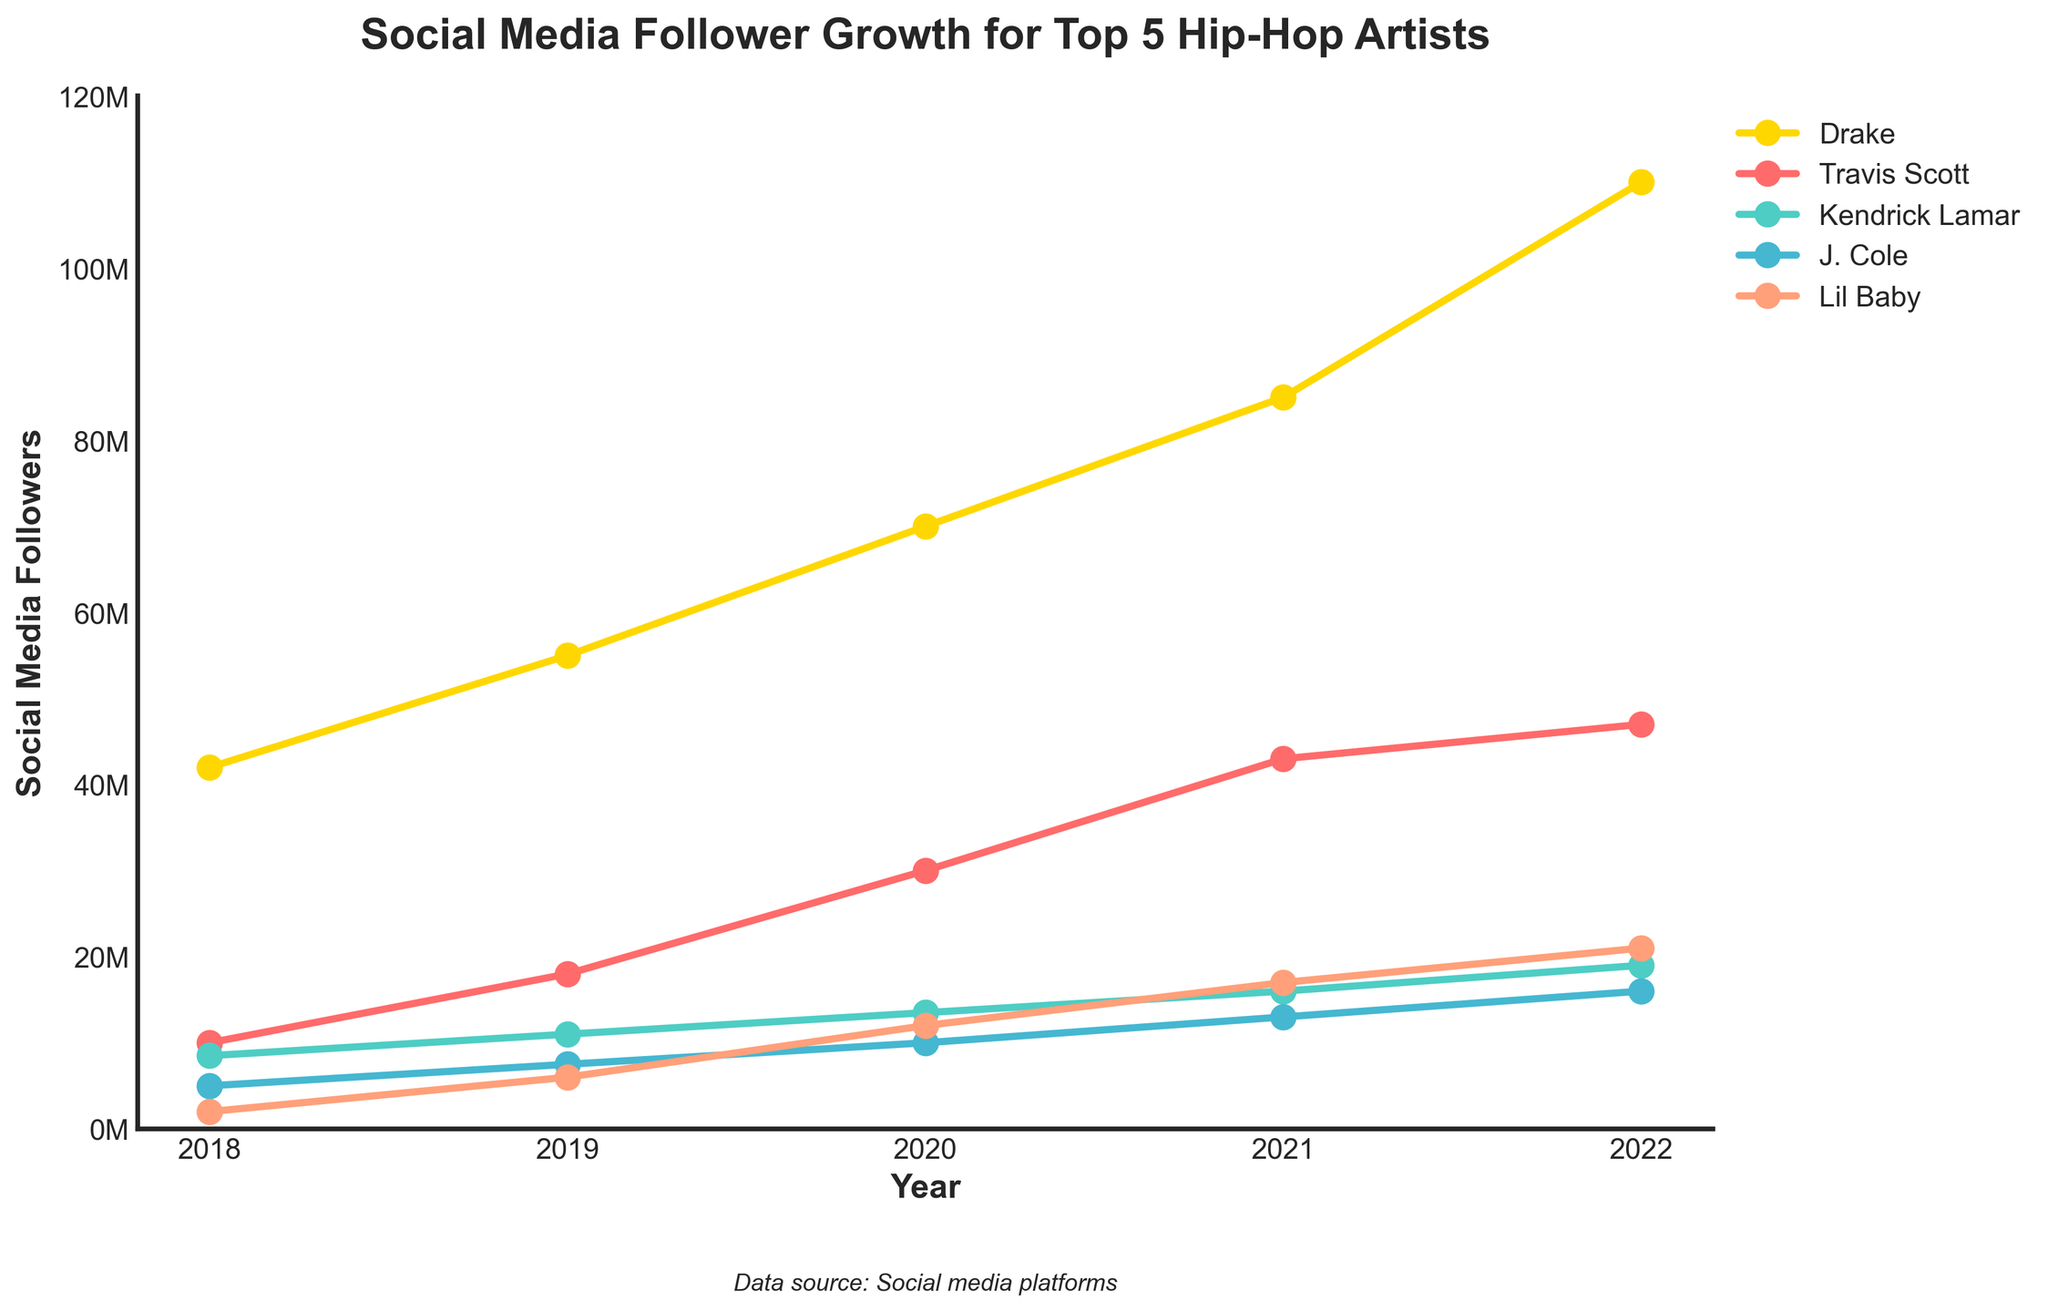What was the difference in social media followers for Lil Baby between 2019 and 2020? In 2019, Lil Baby had 6,000,000 followers, and in 2020, he had 12,000,000 followers. The difference is 12,000,000 - 6,000,000 = 6,000,000 followers.
Answer: 6,000,000 Which artist had the highest social media followers in 2021? In 2021, the artist with the highest social media followers is the one whose line reaches the highest point on the plot. Drake had 85,000,000 followers, which is the highest among the artists.
Answer: Drake What is the average social media followers for J. Cole over the 5-year period? Summing the followers for J. Cole from 2018 to 2022 (5,000,000 + 7,500,000 + 10,000,000 + 13,000,000 + 16,000,000) gives a total of 51,500,000. Dividing by 5 gives an average of 51,500,000 / 5 = 10,300,000 followers.
Answer: 10,300,000 By how much did Kendrick Lamar's followers increase from 2018 to 2022? In 2018, Kendrick Lamar had 8,500,000 followers and in 2022, he had 19,000,000 followers. The increase is 19,000,000 - 8,500,000 = 10,500,000 followers.
Answer: 10,500,000 Which artist showed the highest percent increase in followers from 2018 to 2022? To find the percent increase: [(followers in 2022 - followers in 2018) / followers in 2018] * 100. Calculating for all artists:
- Drake: [(110,000,000 - 42,000,000) / 42,000,000] * 100 = ~161.9%
- Travis Scott: [(47,000,000 - 10,000,000) / 10,000,000] * 100 = 370%
- Kendrick Lamar: [(19,000,000 - 8,500,000) / 8,500,000] * 100 = ~123.5%
- J. Cole: [(16,000,000 - 5,000,000) / 5,000,000] * 100 = 220%
- Lil Baby: [(21,000,000 - 2,000,000) / 2,000,000] * 100 = 950%
Lil Baby showed the highest percent increase.
Answer: Lil Baby Which year did Travis Scott see the highest increase in followers compared to the previous year? By visually inspecting the plot and checking the data, the increase year-by-year for Travis Scott is:
- 2018 to 2019: 18,000,000 - 10,000,000 = 8,000,000
- 2019 to 2020: 30,000,000 - 18,000,000 = 12,000,000
- 2020 to 2021: 43,000,000 - 30,000,000 = 13,000,000
- 2021 to 2022: 47,000,000 - 43,000,000 = 4,000,000
Travis Scott saw the highest increase in followers from 2020 to 2021.
Answer: 2020 to 2021 What is the combined followers for Drake and Kendrick Lamar in 2020? In 2020, Drake had 70,000,000 followers and Kendrick Lamar had 13,500,000 followers. The combined followers are 70,000,000 + 13,500,000 = 83,500,000.
Answer: 83,500,000 Based on the plot, which artist had a consistent increase in followers every year? By visually inspecting the plot, all artists' lines show an upward trend every year, indicating a consistent increase.
Answer: All five artists 